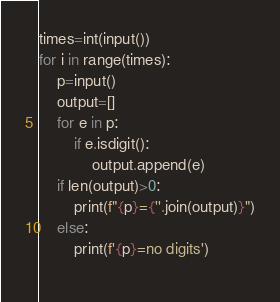Convert code to text. <code><loc_0><loc_0><loc_500><loc_500><_Python_>times=int(input())
for i in range(times):
    p=input()
    output=[]
    for e in p:
        if e.isdigit():
            output.append(e)
    if len(output)>0:
        print(f"{p}={''.join(output)}")
    else:
        print(f'{p}=no digits')
    </code> 